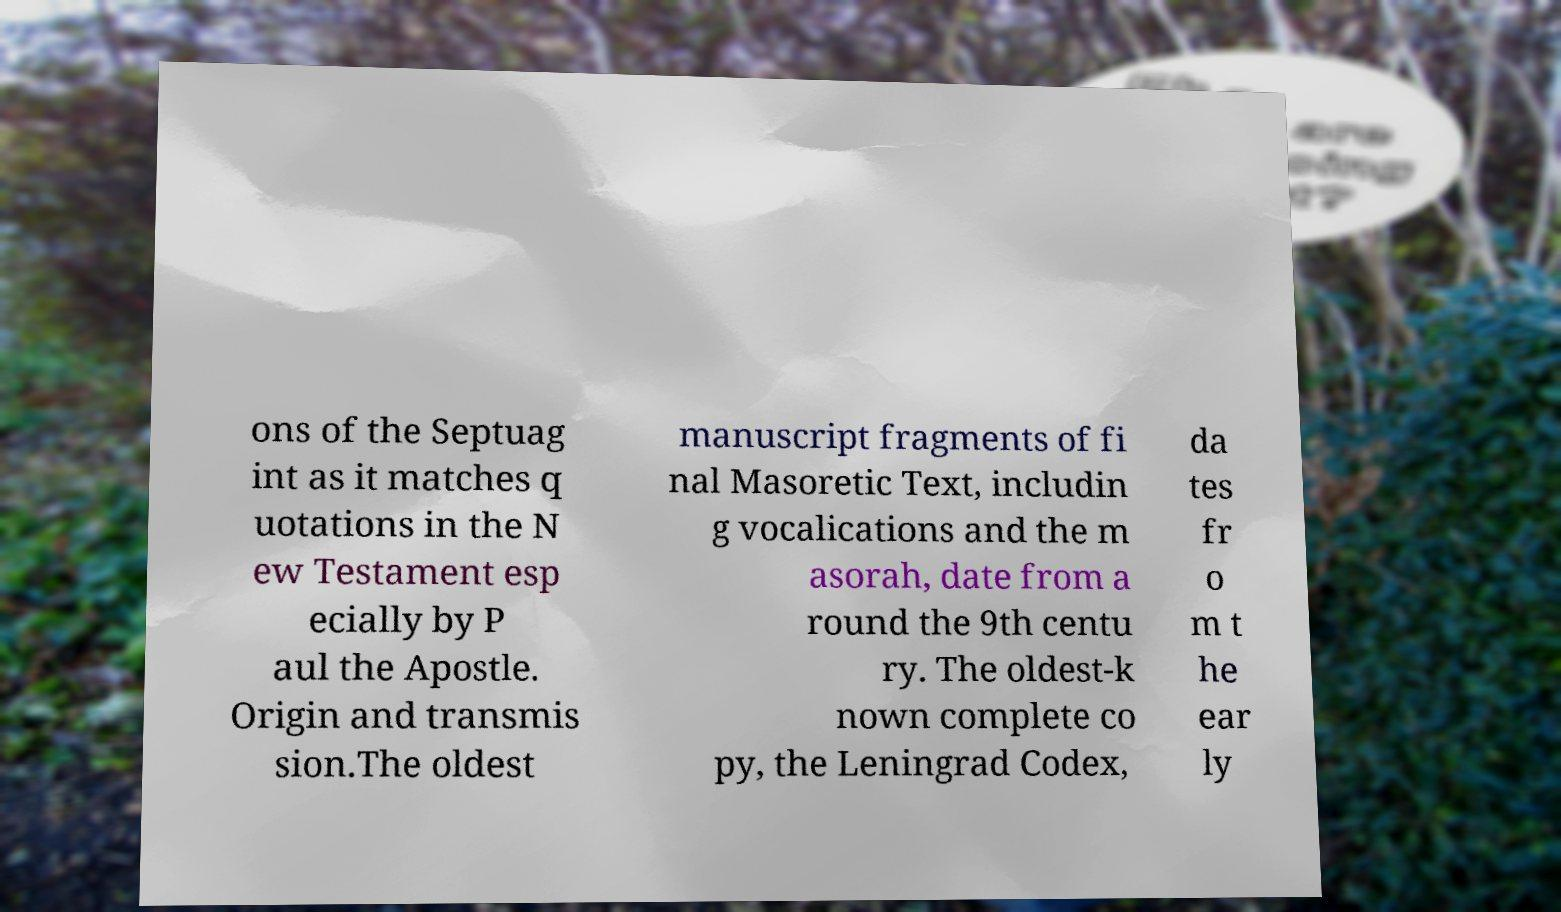Please read and relay the text visible in this image. What does it say? ons of the Septuag int as it matches q uotations in the N ew Testament esp ecially by P aul the Apostle. Origin and transmis sion.The oldest manuscript fragments of fi nal Masoretic Text, includin g vocalications and the m asorah, date from a round the 9th centu ry. The oldest-k nown complete co py, the Leningrad Codex, da tes fr o m t he ear ly 